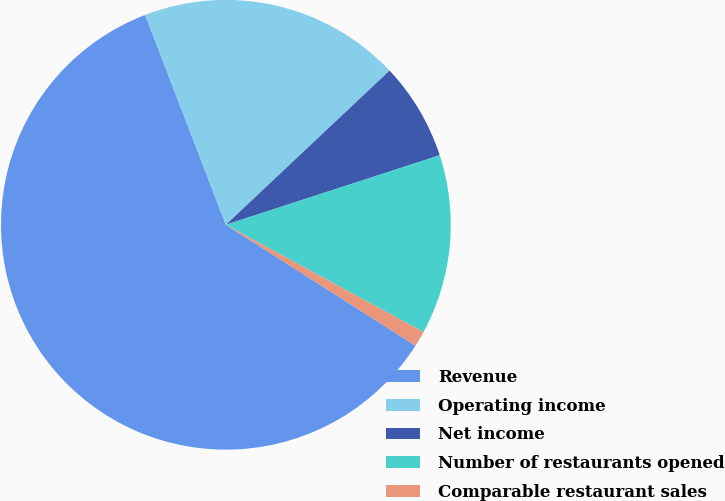<chart> <loc_0><loc_0><loc_500><loc_500><pie_chart><fcel>Revenue<fcel>Operating income<fcel>Net income<fcel>Number of restaurants opened<fcel>Comparable restaurant sales<nl><fcel>60.12%<fcel>18.82%<fcel>7.02%<fcel>12.92%<fcel>1.12%<nl></chart> 